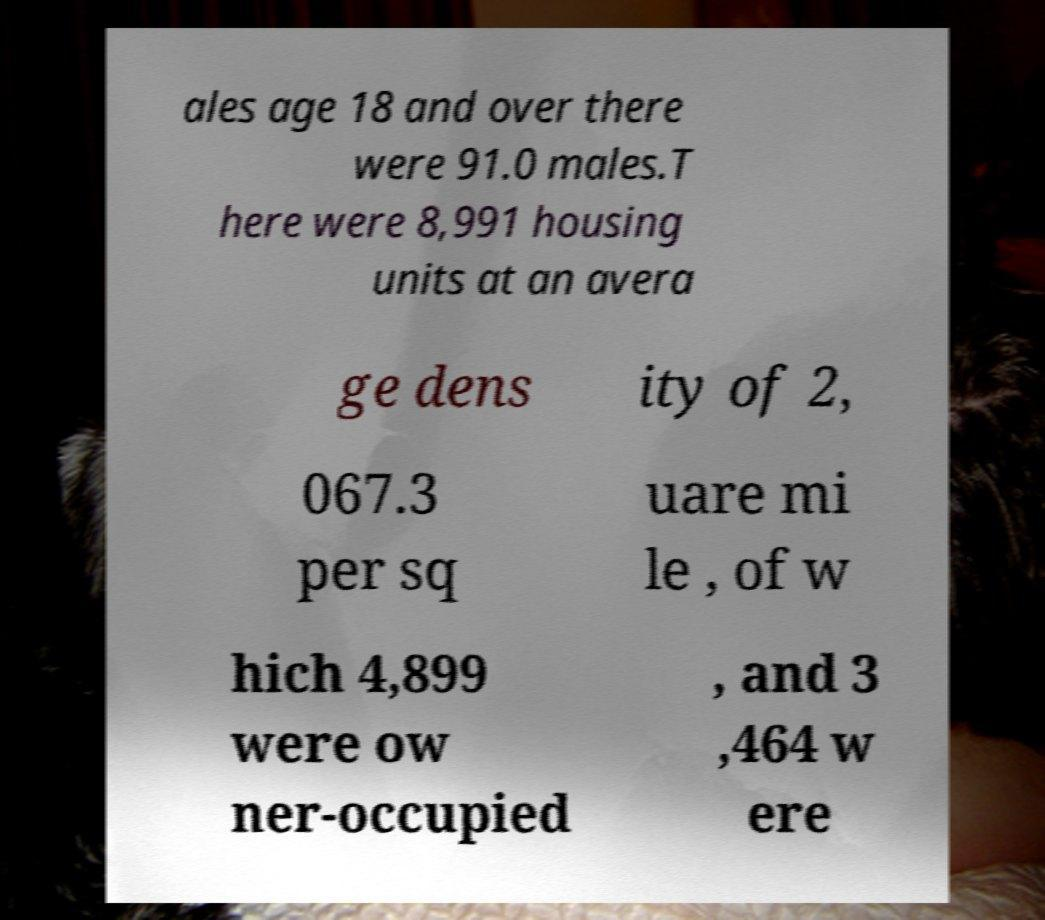There's text embedded in this image that I need extracted. Can you transcribe it verbatim? ales age 18 and over there were 91.0 males.T here were 8,991 housing units at an avera ge dens ity of 2, 067.3 per sq uare mi le , of w hich 4,899 were ow ner-occupied , and 3 ,464 w ere 